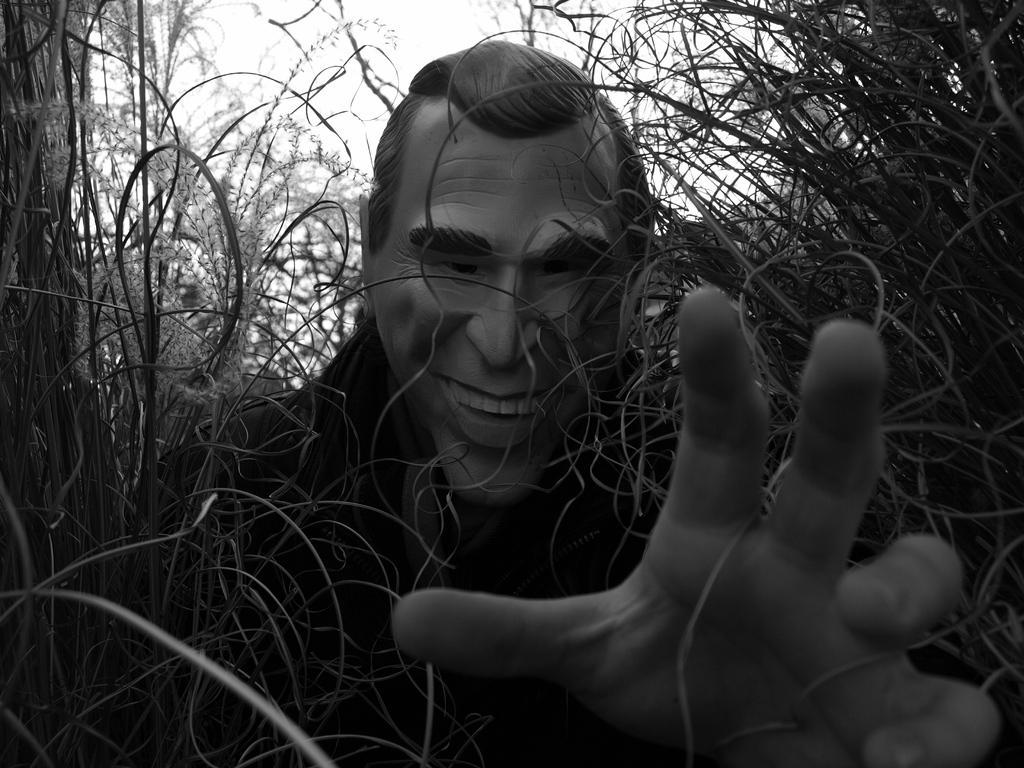Can you describe this image briefly? This is a black and white image. In this image I can see a person's stature and in the right bottom corner I can see a hand. I can see grass and plants around the statue. 